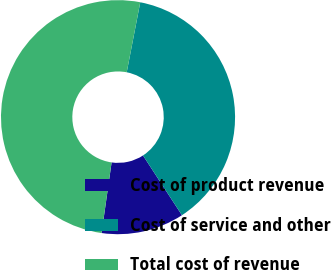Convert chart to OTSL. <chart><loc_0><loc_0><loc_500><loc_500><pie_chart><fcel>Cost of product revenue<fcel>Cost of service and other<fcel>Total cost of revenue<nl><fcel>11.44%<fcel>37.76%<fcel>50.79%<nl></chart> 